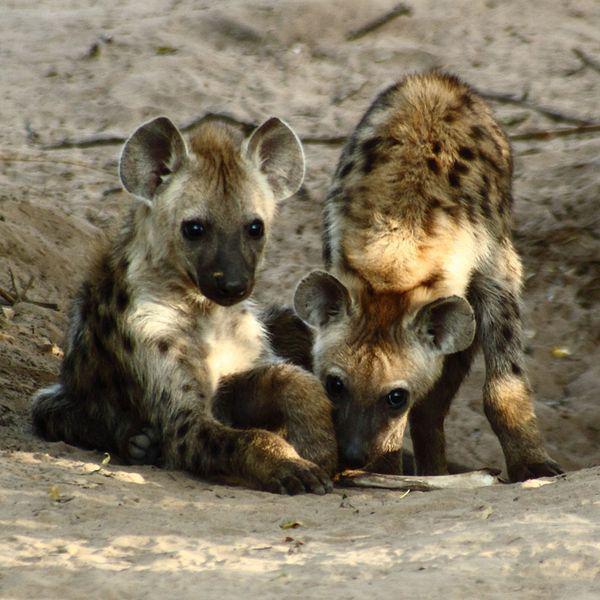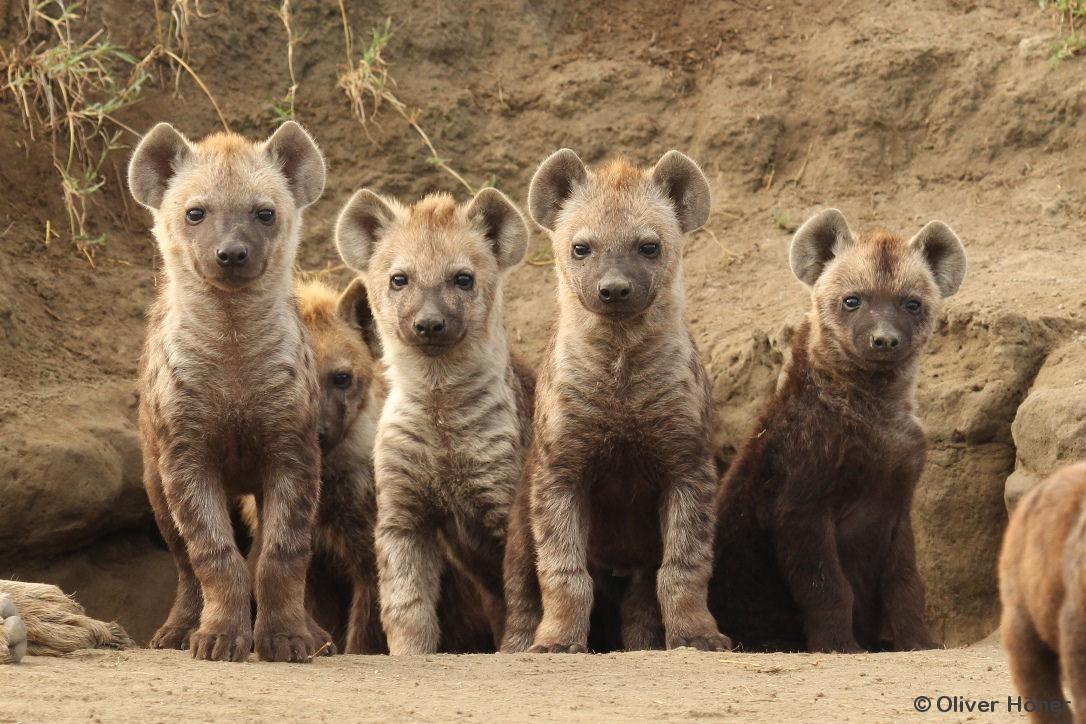The first image is the image on the left, the second image is the image on the right. Considering the images on both sides, is "there are a minimum of 7 hyenas present." valid? Answer yes or no. Yes. 